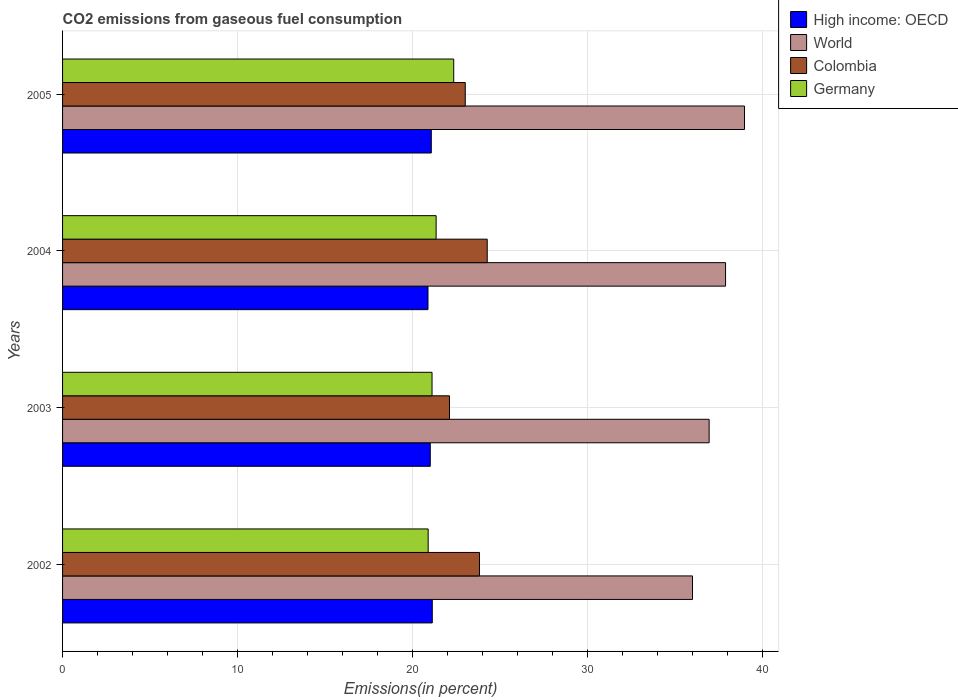How many groups of bars are there?
Offer a terse response. 4. Are the number of bars on each tick of the Y-axis equal?
Provide a succinct answer. Yes. How many bars are there on the 2nd tick from the top?
Provide a succinct answer. 4. How many bars are there on the 2nd tick from the bottom?
Ensure brevity in your answer.  4. What is the total CO2 emitted in Germany in 2003?
Provide a succinct answer. 21.11. Across all years, what is the maximum total CO2 emitted in Colombia?
Give a very brief answer. 24.26. Across all years, what is the minimum total CO2 emitted in High income: OECD?
Offer a very short reply. 20.87. In which year was the total CO2 emitted in High income: OECD maximum?
Provide a succinct answer. 2002. What is the total total CO2 emitted in World in the graph?
Your answer should be very brief. 149.75. What is the difference between the total CO2 emitted in High income: OECD in 2003 and that in 2004?
Make the answer very short. 0.13. What is the difference between the total CO2 emitted in High income: OECD in 2005 and the total CO2 emitted in Colombia in 2002?
Give a very brief answer. -2.75. What is the average total CO2 emitted in Colombia per year?
Provide a short and direct response. 23.29. In the year 2002, what is the difference between the total CO2 emitted in Colombia and total CO2 emitted in World?
Your response must be concise. -12.17. In how many years, is the total CO2 emitted in Colombia greater than 28 %?
Your response must be concise. 0. What is the ratio of the total CO2 emitted in Germany in 2004 to that in 2005?
Provide a short and direct response. 0.96. What is the difference between the highest and the second highest total CO2 emitted in Colombia?
Provide a succinct answer. 0.44. What is the difference between the highest and the lowest total CO2 emitted in High income: OECD?
Provide a succinct answer. 0.24. In how many years, is the total CO2 emitted in Colombia greater than the average total CO2 emitted in Colombia taken over all years?
Give a very brief answer. 2. What does the 1st bar from the bottom in 2005 represents?
Offer a terse response. High income: OECD. How many bars are there?
Ensure brevity in your answer.  16. Are all the bars in the graph horizontal?
Your answer should be compact. Yes. Are the values on the major ticks of X-axis written in scientific E-notation?
Your answer should be compact. No. How are the legend labels stacked?
Make the answer very short. Vertical. What is the title of the graph?
Offer a terse response. CO2 emissions from gaseous fuel consumption. Does "Indonesia" appear as one of the legend labels in the graph?
Your answer should be very brief. No. What is the label or title of the X-axis?
Give a very brief answer. Emissions(in percent). What is the Emissions(in percent) in High income: OECD in 2002?
Your response must be concise. 21.12. What is the Emissions(in percent) of World in 2002?
Ensure brevity in your answer.  35.98. What is the Emissions(in percent) in Colombia in 2002?
Ensure brevity in your answer.  23.82. What is the Emissions(in percent) in Germany in 2002?
Provide a succinct answer. 20.88. What is the Emissions(in percent) of High income: OECD in 2003?
Make the answer very short. 21. What is the Emissions(in percent) in World in 2003?
Your answer should be compact. 36.93. What is the Emissions(in percent) in Colombia in 2003?
Give a very brief answer. 22.1. What is the Emissions(in percent) of Germany in 2003?
Ensure brevity in your answer.  21.11. What is the Emissions(in percent) of High income: OECD in 2004?
Keep it short and to the point. 20.87. What is the Emissions(in percent) of World in 2004?
Offer a terse response. 37.87. What is the Emissions(in percent) in Colombia in 2004?
Ensure brevity in your answer.  24.26. What is the Emissions(in percent) of Germany in 2004?
Offer a terse response. 21.34. What is the Emissions(in percent) in High income: OECD in 2005?
Your response must be concise. 21.06. What is the Emissions(in percent) of World in 2005?
Your answer should be very brief. 38.95. What is the Emissions(in percent) of Colombia in 2005?
Make the answer very short. 23. What is the Emissions(in percent) in Germany in 2005?
Make the answer very short. 22.34. Across all years, what is the maximum Emissions(in percent) in High income: OECD?
Offer a very short reply. 21.12. Across all years, what is the maximum Emissions(in percent) of World?
Your response must be concise. 38.95. Across all years, what is the maximum Emissions(in percent) in Colombia?
Keep it short and to the point. 24.26. Across all years, what is the maximum Emissions(in percent) of Germany?
Your response must be concise. 22.34. Across all years, what is the minimum Emissions(in percent) in High income: OECD?
Provide a succinct answer. 20.87. Across all years, what is the minimum Emissions(in percent) of World?
Ensure brevity in your answer.  35.98. Across all years, what is the minimum Emissions(in percent) of Colombia?
Your answer should be compact. 22.1. Across all years, what is the minimum Emissions(in percent) in Germany?
Your answer should be very brief. 20.88. What is the total Emissions(in percent) of High income: OECD in the graph?
Make the answer very short. 84.06. What is the total Emissions(in percent) of World in the graph?
Provide a succinct answer. 149.75. What is the total Emissions(in percent) of Colombia in the graph?
Your response must be concise. 93.18. What is the total Emissions(in percent) of Germany in the graph?
Ensure brevity in your answer.  85.67. What is the difference between the Emissions(in percent) in High income: OECD in 2002 and that in 2003?
Keep it short and to the point. 0.12. What is the difference between the Emissions(in percent) of World in 2002 and that in 2003?
Provide a short and direct response. -0.95. What is the difference between the Emissions(in percent) of Colombia in 2002 and that in 2003?
Give a very brief answer. 1.71. What is the difference between the Emissions(in percent) in Germany in 2002 and that in 2003?
Provide a short and direct response. -0.22. What is the difference between the Emissions(in percent) in High income: OECD in 2002 and that in 2004?
Give a very brief answer. 0.24. What is the difference between the Emissions(in percent) of World in 2002 and that in 2004?
Make the answer very short. -1.89. What is the difference between the Emissions(in percent) of Colombia in 2002 and that in 2004?
Keep it short and to the point. -0.44. What is the difference between the Emissions(in percent) of Germany in 2002 and that in 2004?
Offer a very short reply. -0.45. What is the difference between the Emissions(in percent) in High income: OECD in 2002 and that in 2005?
Keep it short and to the point. 0.06. What is the difference between the Emissions(in percent) of World in 2002 and that in 2005?
Keep it short and to the point. -2.97. What is the difference between the Emissions(in percent) in Colombia in 2002 and that in 2005?
Provide a succinct answer. 0.81. What is the difference between the Emissions(in percent) of Germany in 2002 and that in 2005?
Offer a terse response. -1.46. What is the difference between the Emissions(in percent) of High income: OECD in 2003 and that in 2004?
Ensure brevity in your answer.  0.13. What is the difference between the Emissions(in percent) in World in 2003 and that in 2004?
Make the answer very short. -0.94. What is the difference between the Emissions(in percent) in Colombia in 2003 and that in 2004?
Your response must be concise. -2.16. What is the difference between the Emissions(in percent) in Germany in 2003 and that in 2004?
Provide a short and direct response. -0.23. What is the difference between the Emissions(in percent) of High income: OECD in 2003 and that in 2005?
Make the answer very short. -0.06. What is the difference between the Emissions(in percent) in World in 2003 and that in 2005?
Offer a terse response. -2.02. What is the difference between the Emissions(in percent) in Colombia in 2003 and that in 2005?
Give a very brief answer. -0.9. What is the difference between the Emissions(in percent) of Germany in 2003 and that in 2005?
Your answer should be compact. -1.24. What is the difference between the Emissions(in percent) of High income: OECD in 2004 and that in 2005?
Your answer should be compact. -0.19. What is the difference between the Emissions(in percent) of World in 2004 and that in 2005?
Your response must be concise. -1.08. What is the difference between the Emissions(in percent) of Colombia in 2004 and that in 2005?
Your answer should be compact. 1.26. What is the difference between the Emissions(in percent) in Germany in 2004 and that in 2005?
Provide a succinct answer. -1.01. What is the difference between the Emissions(in percent) in High income: OECD in 2002 and the Emissions(in percent) in World in 2003?
Your response must be concise. -15.82. What is the difference between the Emissions(in percent) in High income: OECD in 2002 and the Emissions(in percent) in Colombia in 2003?
Your answer should be compact. -0.98. What is the difference between the Emissions(in percent) of High income: OECD in 2002 and the Emissions(in percent) of Germany in 2003?
Your answer should be compact. 0.01. What is the difference between the Emissions(in percent) in World in 2002 and the Emissions(in percent) in Colombia in 2003?
Your response must be concise. 13.88. What is the difference between the Emissions(in percent) of World in 2002 and the Emissions(in percent) of Germany in 2003?
Offer a very short reply. 14.88. What is the difference between the Emissions(in percent) of Colombia in 2002 and the Emissions(in percent) of Germany in 2003?
Give a very brief answer. 2.71. What is the difference between the Emissions(in percent) in High income: OECD in 2002 and the Emissions(in percent) in World in 2004?
Your answer should be very brief. -16.75. What is the difference between the Emissions(in percent) in High income: OECD in 2002 and the Emissions(in percent) in Colombia in 2004?
Offer a very short reply. -3.14. What is the difference between the Emissions(in percent) in High income: OECD in 2002 and the Emissions(in percent) in Germany in 2004?
Offer a very short reply. -0.22. What is the difference between the Emissions(in percent) in World in 2002 and the Emissions(in percent) in Colombia in 2004?
Offer a terse response. 11.73. What is the difference between the Emissions(in percent) of World in 2002 and the Emissions(in percent) of Germany in 2004?
Offer a terse response. 14.65. What is the difference between the Emissions(in percent) in Colombia in 2002 and the Emissions(in percent) in Germany in 2004?
Offer a terse response. 2.48. What is the difference between the Emissions(in percent) of High income: OECD in 2002 and the Emissions(in percent) of World in 2005?
Your answer should be very brief. -17.84. What is the difference between the Emissions(in percent) of High income: OECD in 2002 and the Emissions(in percent) of Colombia in 2005?
Make the answer very short. -1.88. What is the difference between the Emissions(in percent) of High income: OECD in 2002 and the Emissions(in percent) of Germany in 2005?
Provide a succinct answer. -1.23. What is the difference between the Emissions(in percent) of World in 2002 and the Emissions(in percent) of Colombia in 2005?
Provide a short and direct response. 12.98. What is the difference between the Emissions(in percent) in World in 2002 and the Emissions(in percent) in Germany in 2005?
Make the answer very short. 13.64. What is the difference between the Emissions(in percent) in Colombia in 2002 and the Emissions(in percent) in Germany in 2005?
Ensure brevity in your answer.  1.47. What is the difference between the Emissions(in percent) in High income: OECD in 2003 and the Emissions(in percent) in World in 2004?
Offer a terse response. -16.87. What is the difference between the Emissions(in percent) of High income: OECD in 2003 and the Emissions(in percent) of Colombia in 2004?
Your answer should be compact. -3.25. What is the difference between the Emissions(in percent) in High income: OECD in 2003 and the Emissions(in percent) in Germany in 2004?
Your response must be concise. -0.33. What is the difference between the Emissions(in percent) of World in 2003 and the Emissions(in percent) of Colombia in 2004?
Provide a short and direct response. 12.68. What is the difference between the Emissions(in percent) of World in 2003 and the Emissions(in percent) of Germany in 2004?
Offer a very short reply. 15.6. What is the difference between the Emissions(in percent) of Colombia in 2003 and the Emissions(in percent) of Germany in 2004?
Provide a succinct answer. 0.76. What is the difference between the Emissions(in percent) of High income: OECD in 2003 and the Emissions(in percent) of World in 2005?
Your answer should be very brief. -17.95. What is the difference between the Emissions(in percent) of High income: OECD in 2003 and the Emissions(in percent) of Colombia in 2005?
Provide a short and direct response. -2. What is the difference between the Emissions(in percent) of High income: OECD in 2003 and the Emissions(in percent) of Germany in 2005?
Provide a succinct answer. -1.34. What is the difference between the Emissions(in percent) in World in 2003 and the Emissions(in percent) in Colombia in 2005?
Your response must be concise. 13.93. What is the difference between the Emissions(in percent) in World in 2003 and the Emissions(in percent) in Germany in 2005?
Offer a terse response. 14.59. What is the difference between the Emissions(in percent) in Colombia in 2003 and the Emissions(in percent) in Germany in 2005?
Offer a terse response. -0.24. What is the difference between the Emissions(in percent) of High income: OECD in 2004 and the Emissions(in percent) of World in 2005?
Keep it short and to the point. -18.08. What is the difference between the Emissions(in percent) in High income: OECD in 2004 and the Emissions(in percent) in Colombia in 2005?
Offer a terse response. -2.13. What is the difference between the Emissions(in percent) in High income: OECD in 2004 and the Emissions(in percent) in Germany in 2005?
Your response must be concise. -1.47. What is the difference between the Emissions(in percent) in World in 2004 and the Emissions(in percent) in Colombia in 2005?
Provide a succinct answer. 14.87. What is the difference between the Emissions(in percent) in World in 2004 and the Emissions(in percent) in Germany in 2005?
Your response must be concise. 15.53. What is the difference between the Emissions(in percent) of Colombia in 2004 and the Emissions(in percent) of Germany in 2005?
Offer a terse response. 1.91. What is the average Emissions(in percent) in High income: OECD per year?
Make the answer very short. 21.02. What is the average Emissions(in percent) in World per year?
Your answer should be very brief. 37.44. What is the average Emissions(in percent) in Colombia per year?
Offer a very short reply. 23.29. What is the average Emissions(in percent) of Germany per year?
Give a very brief answer. 21.42. In the year 2002, what is the difference between the Emissions(in percent) in High income: OECD and Emissions(in percent) in World?
Your response must be concise. -14.86. In the year 2002, what is the difference between the Emissions(in percent) of High income: OECD and Emissions(in percent) of Colombia?
Your answer should be compact. -2.7. In the year 2002, what is the difference between the Emissions(in percent) in High income: OECD and Emissions(in percent) in Germany?
Your answer should be compact. 0.23. In the year 2002, what is the difference between the Emissions(in percent) in World and Emissions(in percent) in Colombia?
Keep it short and to the point. 12.17. In the year 2002, what is the difference between the Emissions(in percent) in World and Emissions(in percent) in Germany?
Keep it short and to the point. 15.1. In the year 2002, what is the difference between the Emissions(in percent) in Colombia and Emissions(in percent) in Germany?
Your answer should be compact. 2.93. In the year 2003, what is the difference between the Emissions(in percent) in High income: OECD and Emissions(in percent) in World?
Offer a very short reply. -15.93. In the year 2003, what is the difference between the Emissions(in percent) in High income: OECD and Emissions(in percent) in Colombia?
Offer a very short reply. -1.1. In the year 2003, what is the difference between the Emissions(in percent) in High income: OECD and Emissions(in percent) in Germany?
Your answer should be very brief. -0.1. In the year 2003, what is the difference between the Emissions(in percent) of World and Emissions(in percent) of Colombia?
Provide a short and direct response. 14.83. In the year 2003, what is the difference between the Emissions(in percent) in World and Emissions(in percent) in Germany?
Your answer should be compact. 15.83. In the year 2003, what is the difference between the Emissions(in percent) of Colombia and Emissions(in percent) of Germany?
Ensure brevity in your answer.  1. In the year 2004, what is the difference between the Emissions(in percent) of High income: OECD and Emissions(in percent) of World?
Provide a short and direct response. -17. In the year 2004, what is the difference between the Emissions(in percent) in High income: OECD and Emissions(in percent) in Colombia?
Keep it short and to the point. -3.38. In the year 2004, what is the difference between the Emissions(in percent) in High income: OECD and Emissions(in percent) in Germany?
Keep it short and to the point. -0.46. In the year 2004, what is the difference between the Emissions(in percent) in World and Emissions(in percent) in Colombia?
Offer a terse response. 13.62. In the year 2004, what is the difference between the Emissions(in percent) of World and Emissions(in percent) of Germany?
Give a very brief answer. 16.53. In the year 2004, what is the difference between the Emissions(in percent) of Colombia and Emissions(in percent) of Germany?
Offer a very short reply. 2.92. In the year 2005, what is the difference between the Emissions(in percent) of High income: OECD and Emissions(in percent) of World?
Ensure brevity in your answer.  -17.89. In the year 2005, what is the difference between the Emissions(in percent) of High income: OECD and Emissions(in percent) of Colombia?
Your response must be concise. -1.94. In the year 2005, what is the difference between the Emissions(in percent) of High income: OECD and Emissions(in percent) of Germany?
Keep it short and to the point. -1.28. In the year 2005, what is the difference between the Emissions(in percent) of World and Emissions(in percent) of Colombia?
Ensure brevity in your answer.  15.95. In the year 2005, what is the difference between the Emissions(in percent) of World and Emissions(in percent) of Germany?
Your answer should be very brief. 16.61. In the year 2005, what is the difference between the Emissions(in percent) in Colombia and Emissions(in percent) in Germany?
Your answer should be compact. 0.66. What is the ratio of the Emissions(in percent) of High income: OECD in 2002 to that in 2003?
Offer a very short reply. 1.01. What is the ratio of the Emissions(in percent) of World in 2002 to that in 2003?
Provide a short and direct response. 0.97. What is the ratio of the Emissions(in percent) of Colombia in 2002 to that in 2003?
Offer a terse response. 1.08. What is the ratio of the Emissions(in percent) of Germany in 2002 to that in 2003?
Your answer should be very brief. 0.99. What is the ratio of the Emissions(in percent) of High income: OECD in 2002 to that in 2004?
Provide a succinct answer. 1.01. What is the ratio of the Emissions(in percent) of World in 2002 to that in 2004?
Give a very brief answer. 0.95. What is the ratio of the Emissions(in percent) of Colombia in 2002 to that in 2004?
Offer a very short reply. 0.98. What is the ratio of the Emissions(in percent) in Germany in 2002 to that in 2004?
Ensure brevity in your answer.  0.98. What is the ratio of the Emissions(in percent) in World in 2002 to that in 2005?
Your answer should be compact. 0.92. What is the ratio of the Emissions(in percent) in Colombia in 2002 to that in 2005?
Give a very brief answer. 1.04. What is the ratio of the Emissions(in percent) of Germany in 2002 to that in 2005?
Keep it short and to the point. 0.93. What is the ratio of the Emissions(in percent) in World in 2003 to that in 2004?
Provide a succinct answer. 0.98. What is the ratio of the Emissions(in percent) in Colombia in 2003 to that in 2004?
Offer a terse response. 0.91. What is the ratio of the Emissions(in percent) in Germany in 2003 to that in 2004?
Make the answer very short. 0.99. What is the ratio of the Emissions(in percent) in High income: OECD in 2003 to that in 2005?
Provide a short and direct response. 1. What is the ratio of the Emissions(in percent) in World in 2003 to that in 2005?
Make the answer very short. 0.95. What is the ratio of the Emissions(in percent) in Colombia in 2003 to that in 2005?
Ensure brevity in your answer.  0.96. What is the ratio of the Emissions(in percent) in Germany in 2003 to that in 2005?
Offer a very short reply. 0.94. What is the ratio of the Emissions(in percent) in High income: OECD in 2004 to that in 2005?
Make the answer very short. 0.99. What is the ratio of the Emissions(in percent) in World in 2004 to that in 2005?
Make the answer very short. 0.97. What is the ratio of the Emissions(in percent) in Colombia in 2004 to that in 2005?
Your answer should be very brief. 1.05. What is the ratio of the Emissions(in percent) of Germany in 2004 to that in 2005?
Provide a short and direct response. 0.95. What is the difference between the highest and the second highest Emissions(in percent) in High income: OECD?
Give a very brief answer. 0.06. What is the difference between the highest and the second highest Emissions(in percent) of World?
Offer a very short reply. 1.08. What is the difference between the highest and the second highest Emissions(in percent) of Colombia?
Provide a short and direct response. 0.44. What is the difference between the highest and the second highest Emissions(in percent) in Germany?
Keep it short and to the point. 1.01. What is the difference between the highest and the lowest Emissions(in percent) in High income: OECD?
Your answer should be compact. 0.24. What is the difference between the highest and the lowest Emissions(in percent) of World?
Provide a short and direct response. 2.97. What is the difference between the highest and the lowest Emissions(in percent) in Colombia?
Keep it short and to the point. 2.16. What is the difference between the highest and the lowest Emissions(in percent) of Germany?
Your answer should be compact. 1.46. 